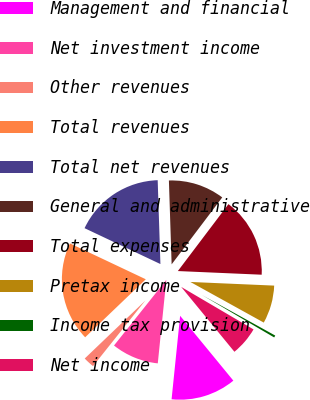<chart> <loc_0><loc_0><loc_500><loc_500><pie_chart><fcel>Management and financial<fcel>Net investment income<fcel>Other revenues<fcel>Total revenues<fcel>Total net revenues<fcel>General and administrative<fcel>Total expenses<fcel>Pretax income<fcel>Income tax provision<fcel>Net income<nl><fcel>12.56%<fcel>9.09%<fcel>2.14%<fcel>19.18%<fcel>17.45%<fcel>10.82%<fcel>15.39%<fcel>7.35%<fcel>0.41%<fcel>5.61%<nl></chart> 